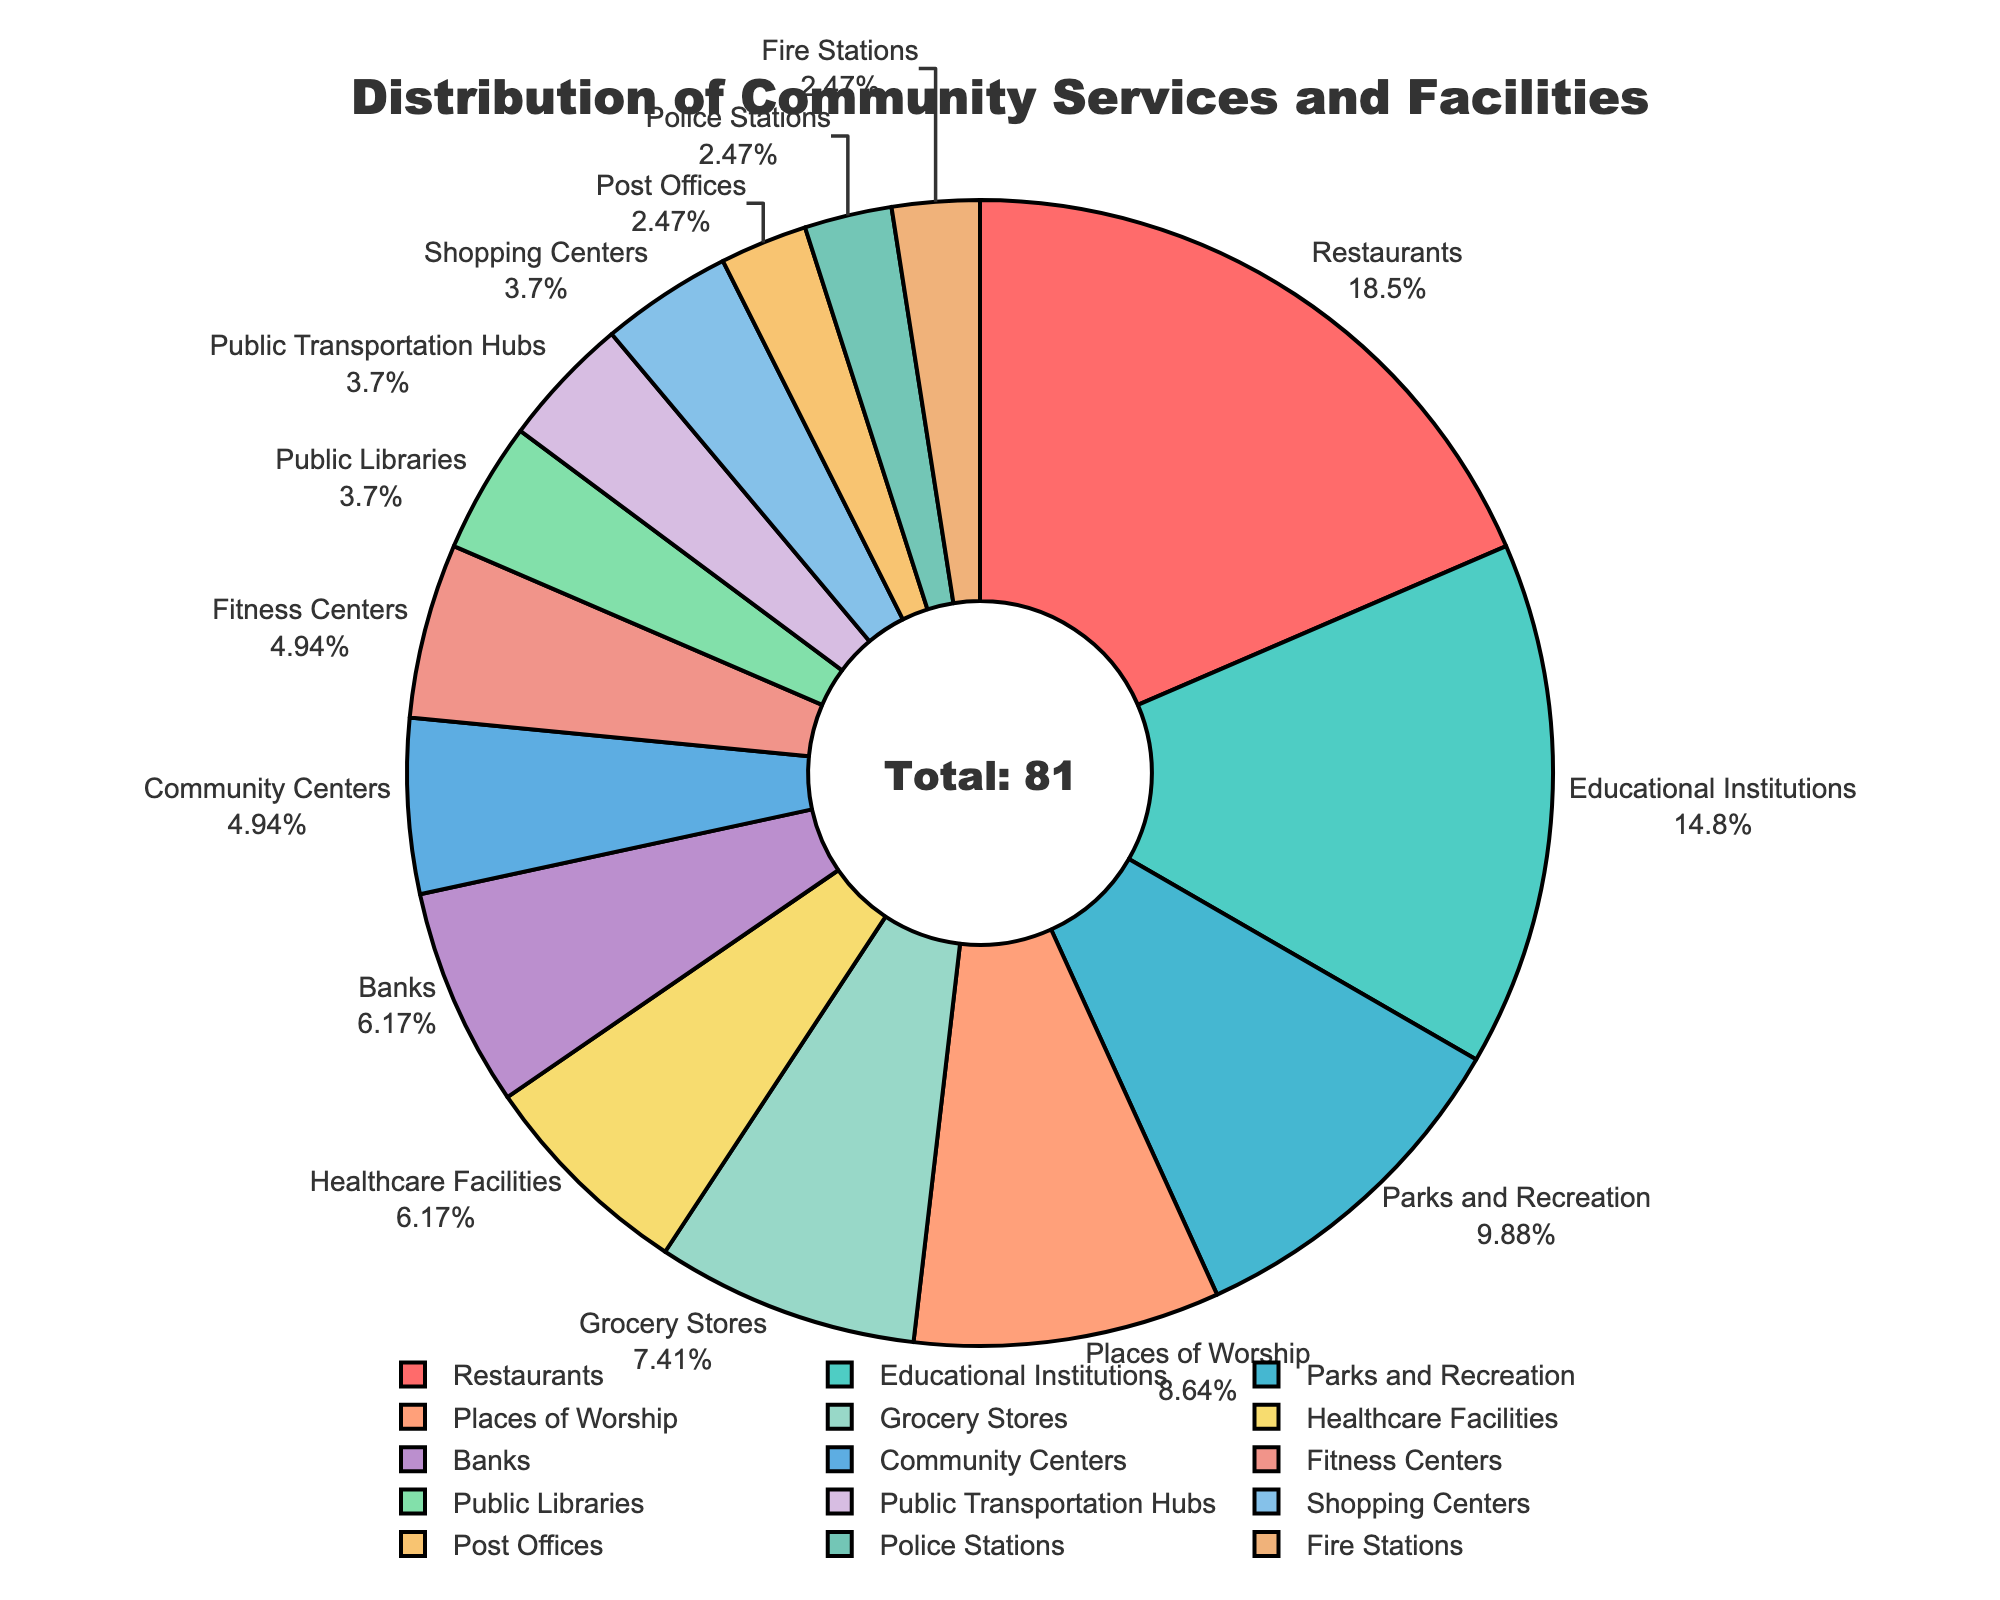what is the percentage of Grocery Stores? The percentage for each category can be found on the pie slice label. For Grocery Stores, locate the label and read the percentage value.
Answer: 9.1% Which category has the highest count? Look for the category label with the largest pie slice. The largest slice represents the highest count.
Answer: Restaurants Which categories have an equal number of services or facilities? Look at the labels of the pie slices with equal sizes and check their counts. "Police Stations", "Post Offices", and "Fire Stations" all have small slices indicating a count of 2 each.
Answer: Police Stations, Post Offices, Fire Stations What is the total count of Healthcare Facilities and Banks? Find the counts for Healthcare Facilities (5) and Banks (5) from their respective pie slices and sum them up. 5 + 5 = 10
Answer: 10 Which category has a slightly higher count compared to Grocery Stores? Compare the pie slice for Grocery Stores, which has a count of 6, with other categories. Places of Worship has a count of 7, which is just 1 more than Grocery Stores.
Answer: Places of Worship What categories make up more than 15% of the total? Check the percentage labels on each pie slice and identify those greater than 15%. Educational Institutions and Restaurants have percentages above 15%.
Answer: Educational Institutions, Restaurants Which categories have less than 5 facilities? Look for slices with counts less than 5. Public Libraries, Police Stations, Fire Stations, Post Offices, and Public Transportation Hubs all have less than 5 facilities.
Answer: Public Libraries, Police Stations, Fire Stations, Post Offices, Public Transportation Hubs How much larger is the count of Educational Institutions than Public Libraries? Calculate the difference by subtracting the count for Public Libraries (3) from the count for Educational Institutions (12). 12 - 3 = 9
Answer: 9 